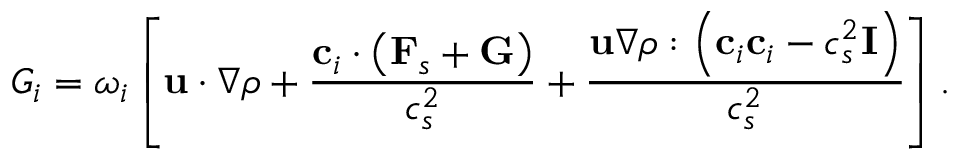<formula> <loc_0><loc_0><loc_500><loc_500>{ G _ { i } } = { \omega _ { i } } \left [ { { u } \cdot \nabla \rho + \frac { { { { c } _ { i } } \cdot \left ( { { { F } _ { s } } + { G } } \right ) } } { { c _ { s } ^ { 2 } } } + \frac { { { u } \nabla \rho \colon \left ( { { { c } _ { i } } { { c } _ { i } } - c _ { s } ^ { 2 } { I } } \right ) } } { { c _ { s } ^ { 2 } } } } \right ] .</formula> 